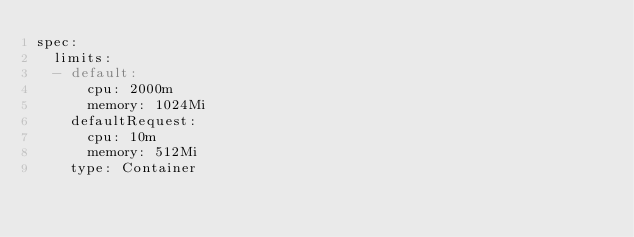Convert code to text. <code><loc_0><loc_0><loc_500><loc_500><_YAML_>spec:
  limits:
  - default:
      cpu: 2000m
      memory: 1024Mi
    defaultRequest:
      cpu: 10m
      memory: 512Mi
    type: Container
</code> 